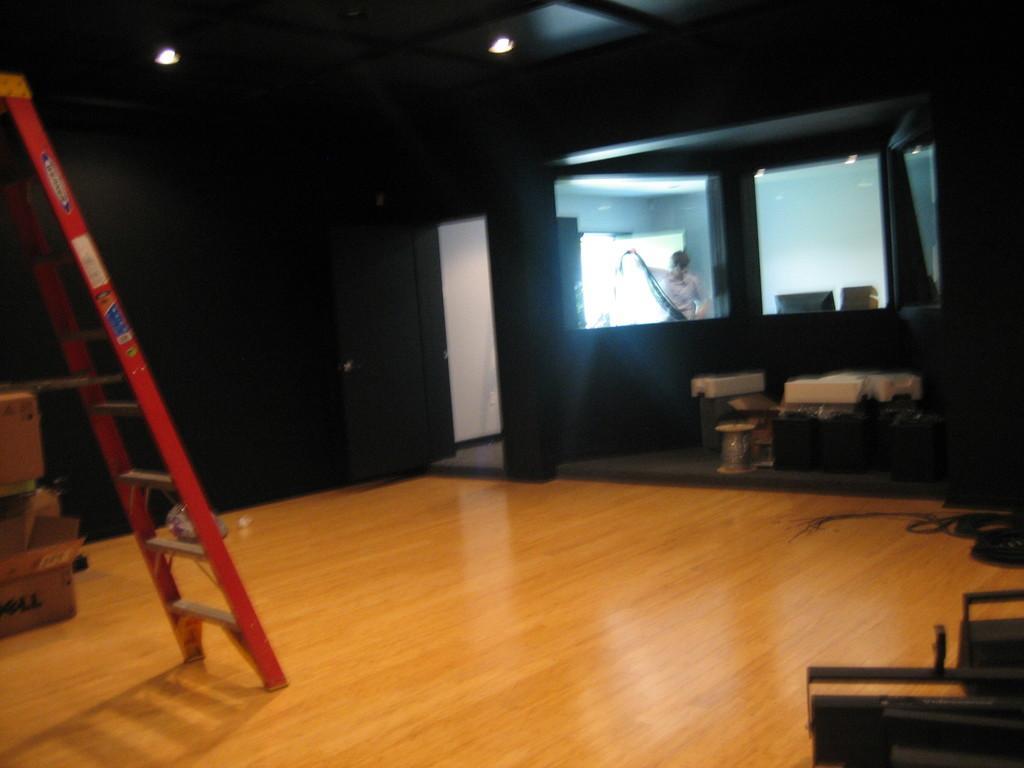How would you summarize this image in a sentence or two? In this picture there is a ladder on the left side of the image and there is a man who is working in the inside a room in the image, there are windows in the background area of the image and there are boxes on the left side of the image. 